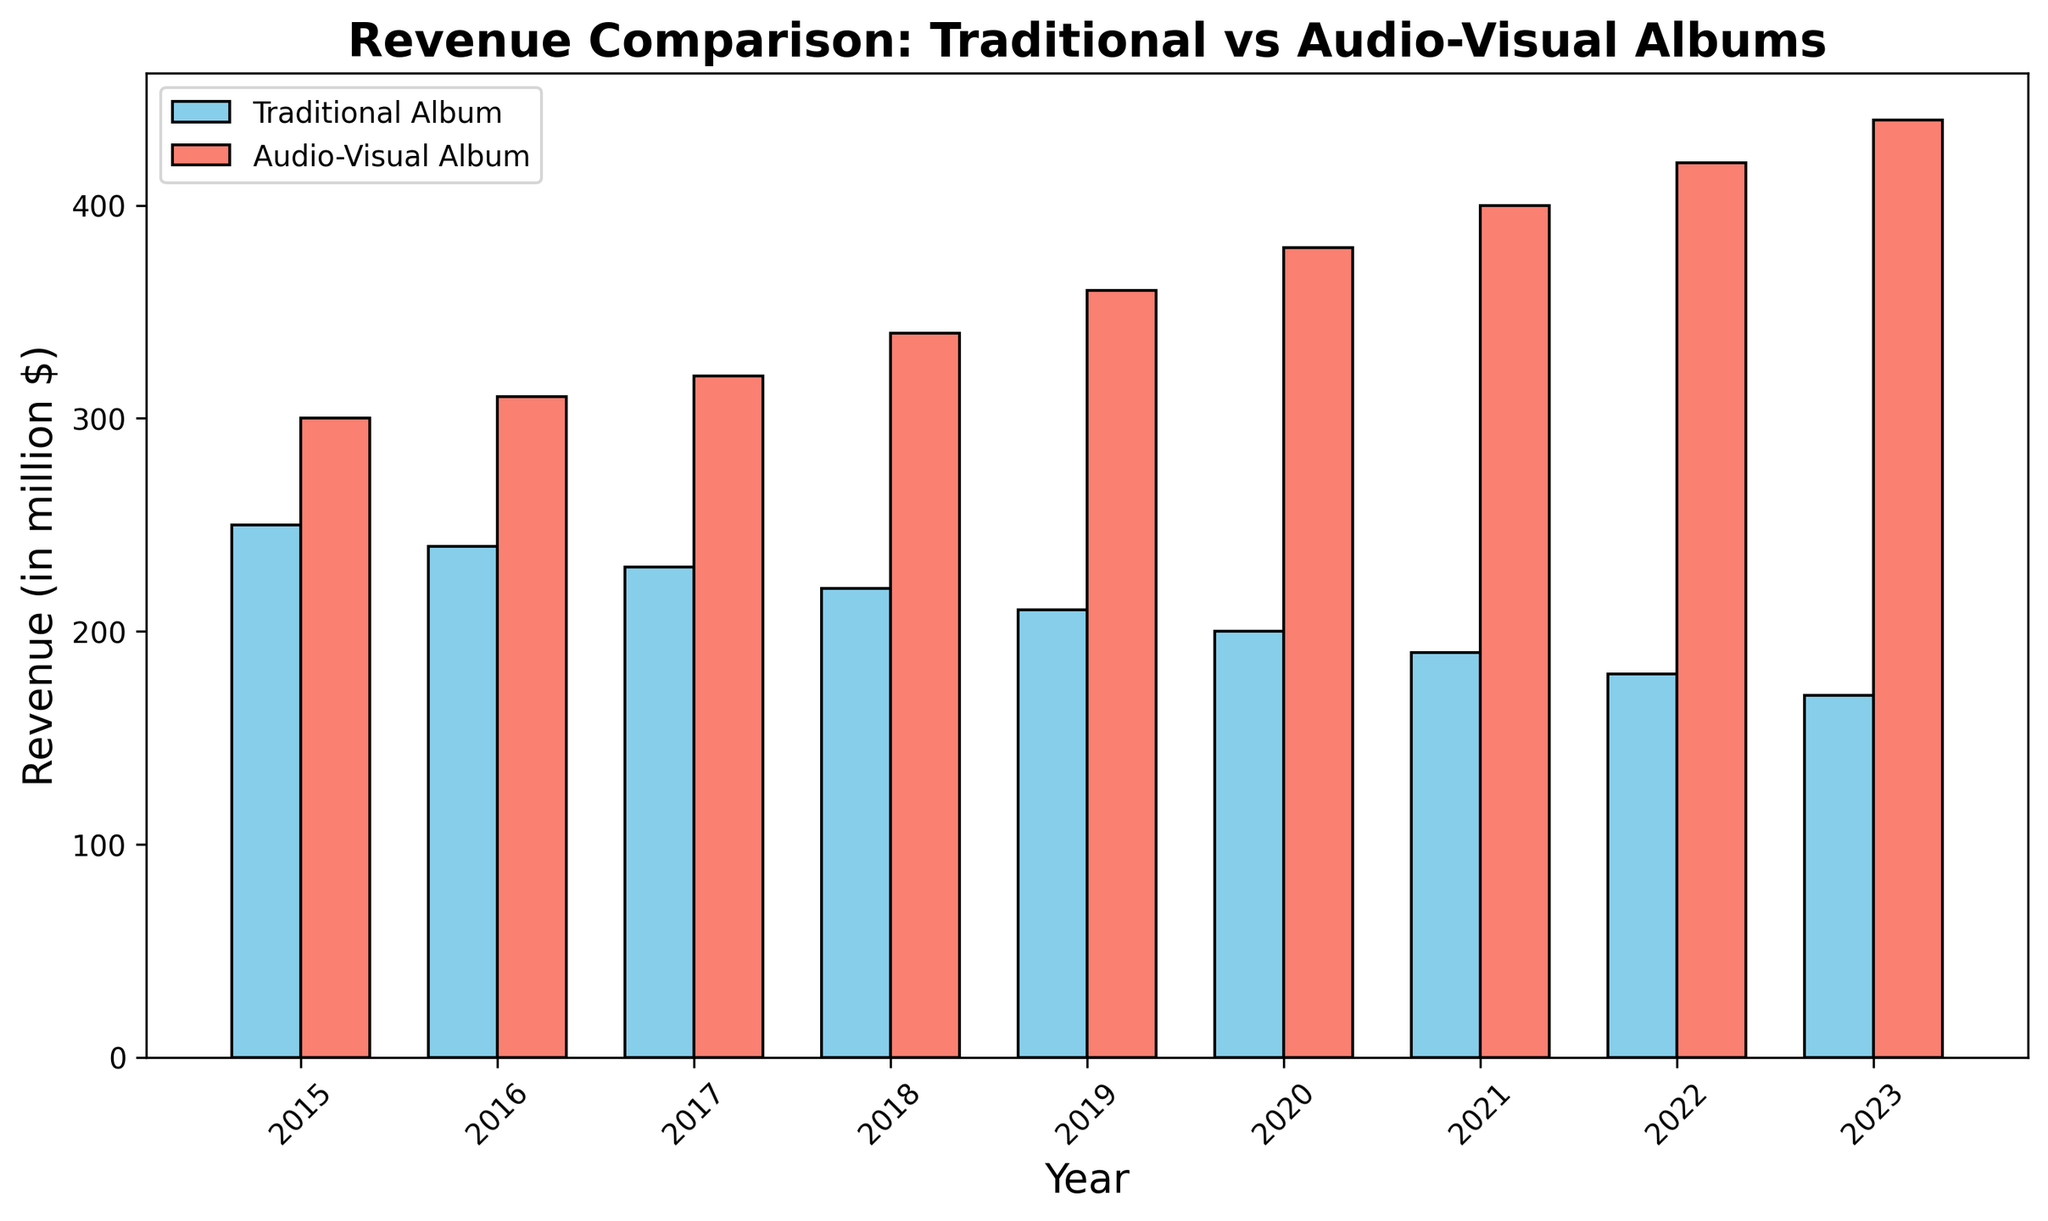Which type of album had higher revenue overall in 2015? To determine which type of album had higher revenue in 2015, we compare the heights of the bars for that year. The bar representing Audio-Visual Album Revenue is taller than the one representing Traditional Album Revenue. Therefore, the Audio-Visual Album Revenue was higher in 2015.
Answer: Audio-Visual Album What was the total revenue generated by traditional albums in 2017 and 2018? Add the revenue figures for traditional albums from 2017 and 2018. For 2017, the revenue is $230 million, and for 2018, it is $220 million. The total revenue is 230 + 220 = 450 million dollars.
Answer: 450 million dollars How did the revenue change for audio-visual albums from 2019 to 2020? The revenue for audio-visual albums in 2019 was $360 million and increased to $380 million in 2020. The change in revenue is 380 - 360 = 20 million dollars.
Answer: Increased by 20 million dollars Which year had the smallest revenue gap between traditional and audio-visual albums? Calculate the revenue difference between traditional and audio-visual albums for each year, then find the year with the smallest gap. 2015: 300 - 250 = 50; 2016: 310 - 240 = 70; 2017: 320 - 230 = 90; 2018: 340 - 220 = 120; 2019: 360 - 210 = 150; 2020: 380 - 200 = 180; 2021: 400 - 190 = 210; 2022: 420 - 180 = 240; 2023: 440 - 170 = 270. The smallest gap is in 2015.
Answer: 2015 How much did the traditional album revenue decrease from 2015 to 2023? Subtract the 2023 revenue from the 2015 revenue for traditional albums. The revenue in 2015 was $250 million and in 2023 it was $170 million. The decrease is 250 - 170 = 80 million dollars.
Answer: Decreased by 80 million dollars Which year saw the largest increase in audio-visual album revenue compared to the previous year? Calculate the year-over-year changes for audio-visual album revenue and identify the largest. Changes: 2016: 310 - 300 = 10; 2017: 320 - 310 = 10; 2018: 340 - 320 = 20; 2019: 360 - 340 = 20; 2020: 380 - 360 = 20; 2021: 400 - 380 = 20; 2022: 420 - 400 = 20; 2023: 440 - 420 = 20. The largest increase, 20 million dollars, occurred from 2017 to 2018, 2018 to 2019, 2019 to 2020, 2020 to 2021, 2021 to 2022, and 2022 to 2023.
Answer: 2018, 2019, 2020, 2021, 2022, 2023 (tie) What is the average revenue for traditional albums over the given years? Add the revenue figures for traditional albums from 2015 to 2023, then divide by the number of years. Sum = 250 + 240 + 230 + 220 + 210 + 200 + 190 + 180 + 170 = 1890 million dollars. The average revenue is 1890/9 ≈ 210 million dollars.
Answer: 210 million dollars Was there any year when traditional album revenue and audio-visual album revenue were equal? Compare the bars for traditional and audio-visual album revenues for each year. There is no year where the bars are of equal height.
Answer: No 